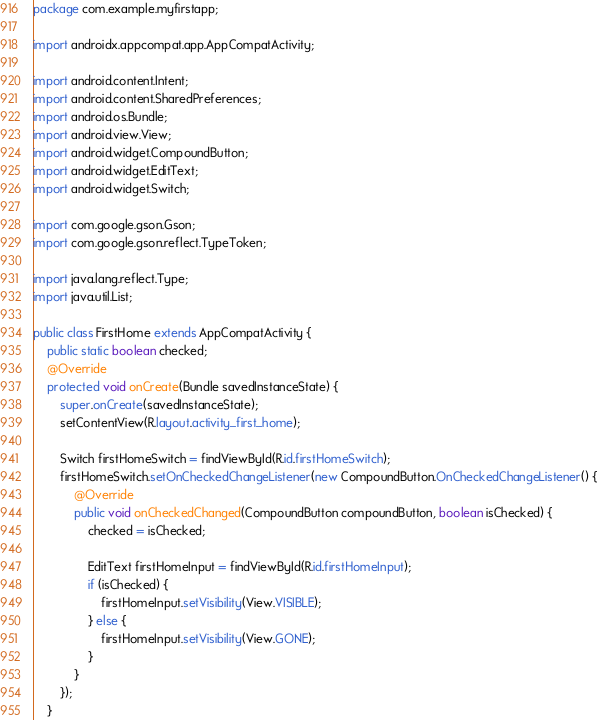Convert code to text. <code><loc_0><loc_0><loc_500><loc_500><_Java_>package com.example.myfirstapp;

import androidx.appcompat.app.AppCompatActivity;

import android.content.Intent;
import android.content.SharedPreferences;
import android.os.Bundle;
import android.view.View;
import android.widget.CompoundButton;
import android.widget.EditText;
import android.widget.Switch;

import com.google.gson.Gson;
import com.google.gson.reflect.TypeToken;

import java.lang.reflect.Type;
import java.util.List;

public class FirstHome extends AppCompatActivity {
    public static boolean checked;
    @Override
    protected void onCreate(Bundle savedInstanceState) {
        super.onCreate(savedInstanceState);
        setContentView(R.layout.activity_first_home);

        Switch firstHomeSwitch = findViewById(R.id.firstHomeSwitch);
        firstHomeSwitch.setOnCheckedChangeListener(new CompoundButton.OnCheckedChangeListener() {
            @Override
            public void onCheckedChanged(CompoundButton compoundButton, boolean isChecked) {
                checked = isChecked;

                EditText firstHomeInput = findViewById(R.id.firstHomeInput);
                if (isChecked) {
                    firstHomeInput.setVisibility(View.VISIBLE);
                } else {
                    firstHomeInput.setVisibility(View.GONE);
                }
            }
        });
    }
</code> 